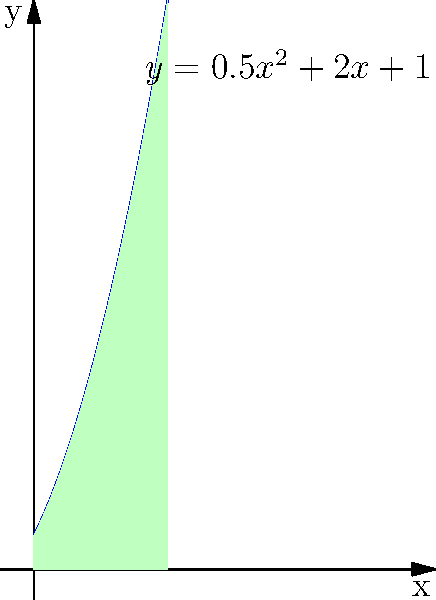As an experienced hiker, you've encountered a unique patch of stinging nettles in a nature reserve. The growth pattern of this patch can be described by the function $f(x) = 0.5x^2 + 2x + 1$, where $x$ is the distance in meters from the trail and $f(x)$ is the height of the nettles in meters. If the patch extends 4 meters from the trail, calculate the total area (in square meters) covered by the stinging nettles. To find the total area covered by the stinging nettles, we need to calculate the integral of the given function from 0 to 4 meters.

Step 1: Set up the integral
$$\text{Area} = \int_0^4 (0.5x^2 + 2x + 1) dx$$

Step 2: Integrate the function
$$\int (0.5x^2 + 2x + 1) dx = \frac{1}{6}x^3 + x^2 + x + C$$

Step 3: Apply the limits of integration
$$\text{Area} = [\frac{1}{6}x^3 + x^2 + x]_0^4$$

Step 4: Evaluate the integral
$$\text{Area} = (\frac{1}{6}(4^3) + 4^2 + 4) - (\frac{1}{6}(0^3) + 0^2 + 0)$$
$$\text{Area} = (\frac{64}{6} + 16 + 4) - 0$$
$$\text{Area} = \frac{64}{6} + 20$$
$$\text{Area} = \frac{184}{6}$$

Step 5: Simplify the result
$$\text{Area} = 30\frac{2}{3} \text{ square meters}$$
Answer: $30\frac{2}{3}$ square meters 